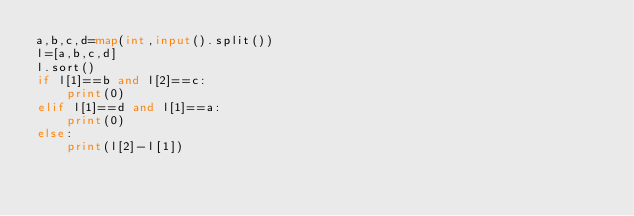Convert code to text. <code><loc_0><loc_0><loc_500><loc_500><_Python_>a,b,c,d=map(int,input().split())
l=[a,b,c,d]
l.sort()
if l[1]==b and l[2]==c:
    print(0)
elif l[1]==d and l[1]==a:
    print(0)
else:
    print(l[2]-l[1])
</code> 